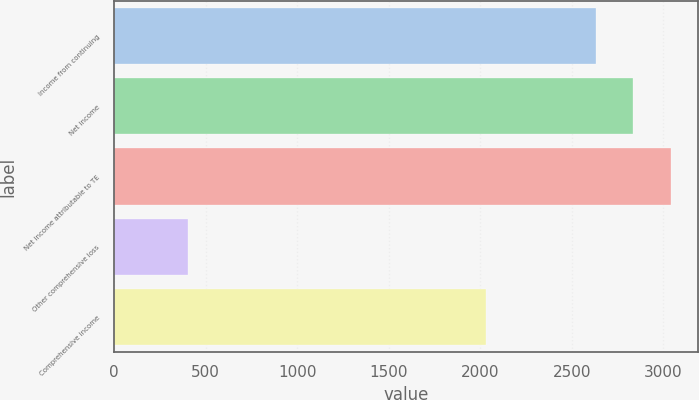Convert chart to OTSL. <chart><loc_0><loc_0><loc_500><loc_500><bar_chart><fcel>Income from continuing<fcel>Net income<fcel>Net income attributable to TE<fcel>Other comprehensive loss<fcel>Comprehensive income<nl><fcel>2633.9<fcel>2836.8<fcel>3039.7<fcel>402<fcel>2029<nl></chart> 